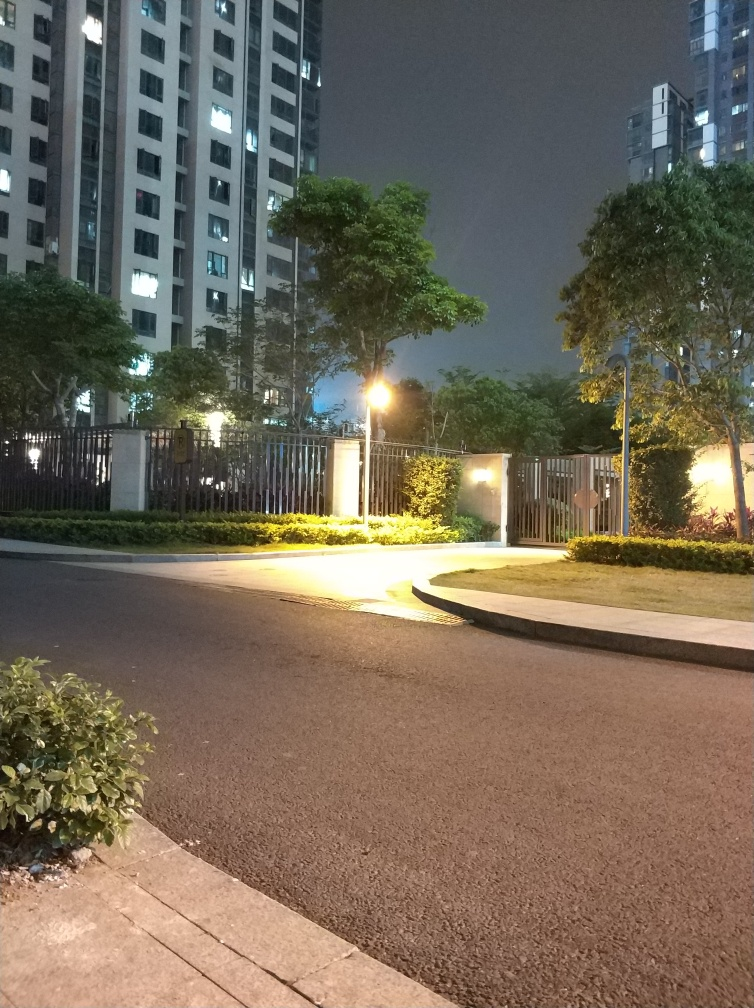Can you describe the type of area shown in the image? The image depicts an urban residential area, likely an apartment complex, with well-maintained landscaping and street lighting that suggests a focus on safety and aesthetic appeal. 